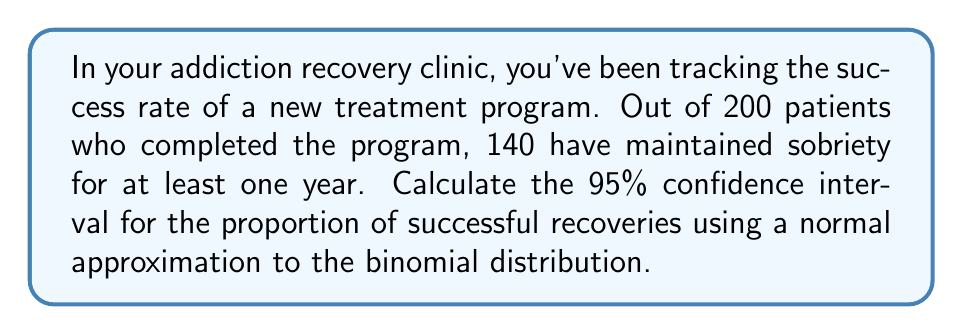Show me your answer to this math problem. Let's approach this step-by-step:

1) First, let's identify our variables:
   $n = 200$ (sample size)
   $X = 140$ (number of successes)
   $\hat{p} = X/n = 140/200 = 0.7$ (sample proportion)

2) For a 95% confidence interval, we use $z_{0.025} = 1.96$

3) The formula for the confidence interval using normal approximation is:

   $$\hat{p} \pm z_{0.025} \sqrt{\frac{\hat{p}(1-\hat{p})}{n}}$$

4) Let's calculate the standard error:

   $$SE = \sqrt{\frac{\hat{p}(1-\hat{p})}{n}} = \sqrt{\frac{0.7(1-0.7)}{200}} = \sqrt{\frac{0.21}{200}} = 0.0324$$

5) Now we can calculate the margin of error:

   $$ME = z_{0.025} * SE = 1.96 * 0.0324 = 0.0635$$

6) Finally, we can compute the confidence interval:

   Lower bound: $0.7 - 0.0635 = 0.6365$
   Upper bound: $0.7 + 0.0635 = 0.7635$

Therefore, the 95% confidence interval is (0.6365, 0.7635).

7) We can interpret this as: We are 95% confident that the true proportion of successful recoveries in the population lies between 63.65% and 76.35%.
Answer: (0.6365, 0.7635) 